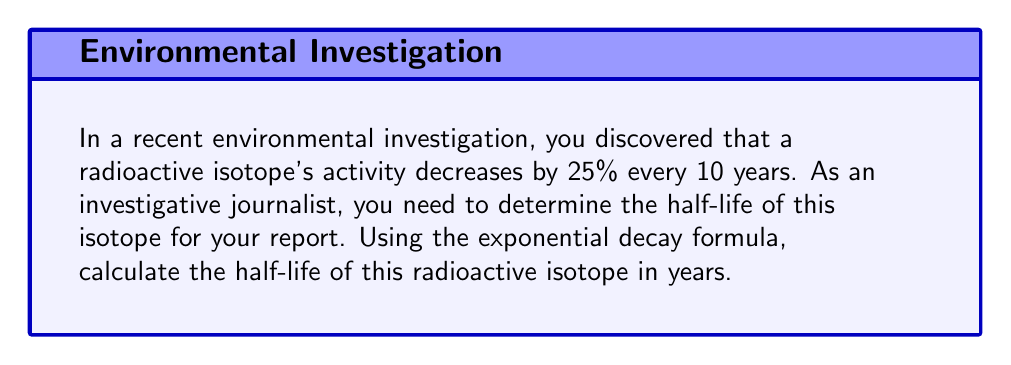Help me with this question. Let's approach this step-by-step:

1) The exponential decay formula is:

   $$ A(t) = A_0 \cdot (1/2)^{t/t_{1/2}} $$

   Where $A(t)$ is the amount at time $t$, $A_0$ is the initial amount, and $t_{1/2}$ is the half-life.

2) We know that after 10 years, the activity is 75% of the original (a 25% decrease). So:

   $$ 0.75 = (1/2)^{10/t_{1/2}} $$

3) Taking the natural log of both sides:

   $$ \ln(0.75) = \ln((1/2)^{10/t_{1/2}}) $$

4) Using the logarithm property $\ln(x^n) = n\ln(x)$:

   $$ \ln(0.75) = \frac{10}{t_{1/2}} \ln(1/2) $$

5) Solving for $t_{1/2}$:

   $$ t_{1/2} = \frac{10 \ln(1/2)}{\ln(0.75)} $$

6) Calculate:
   
   $$ t_{1/2} = \frac{10 \cdot (-0.6931)}{-0.2877} \approx 24.08 $$

Therefore, the half-life of the radioactive isotope is approximately 24.08 years.
Answer: 24.08 years 